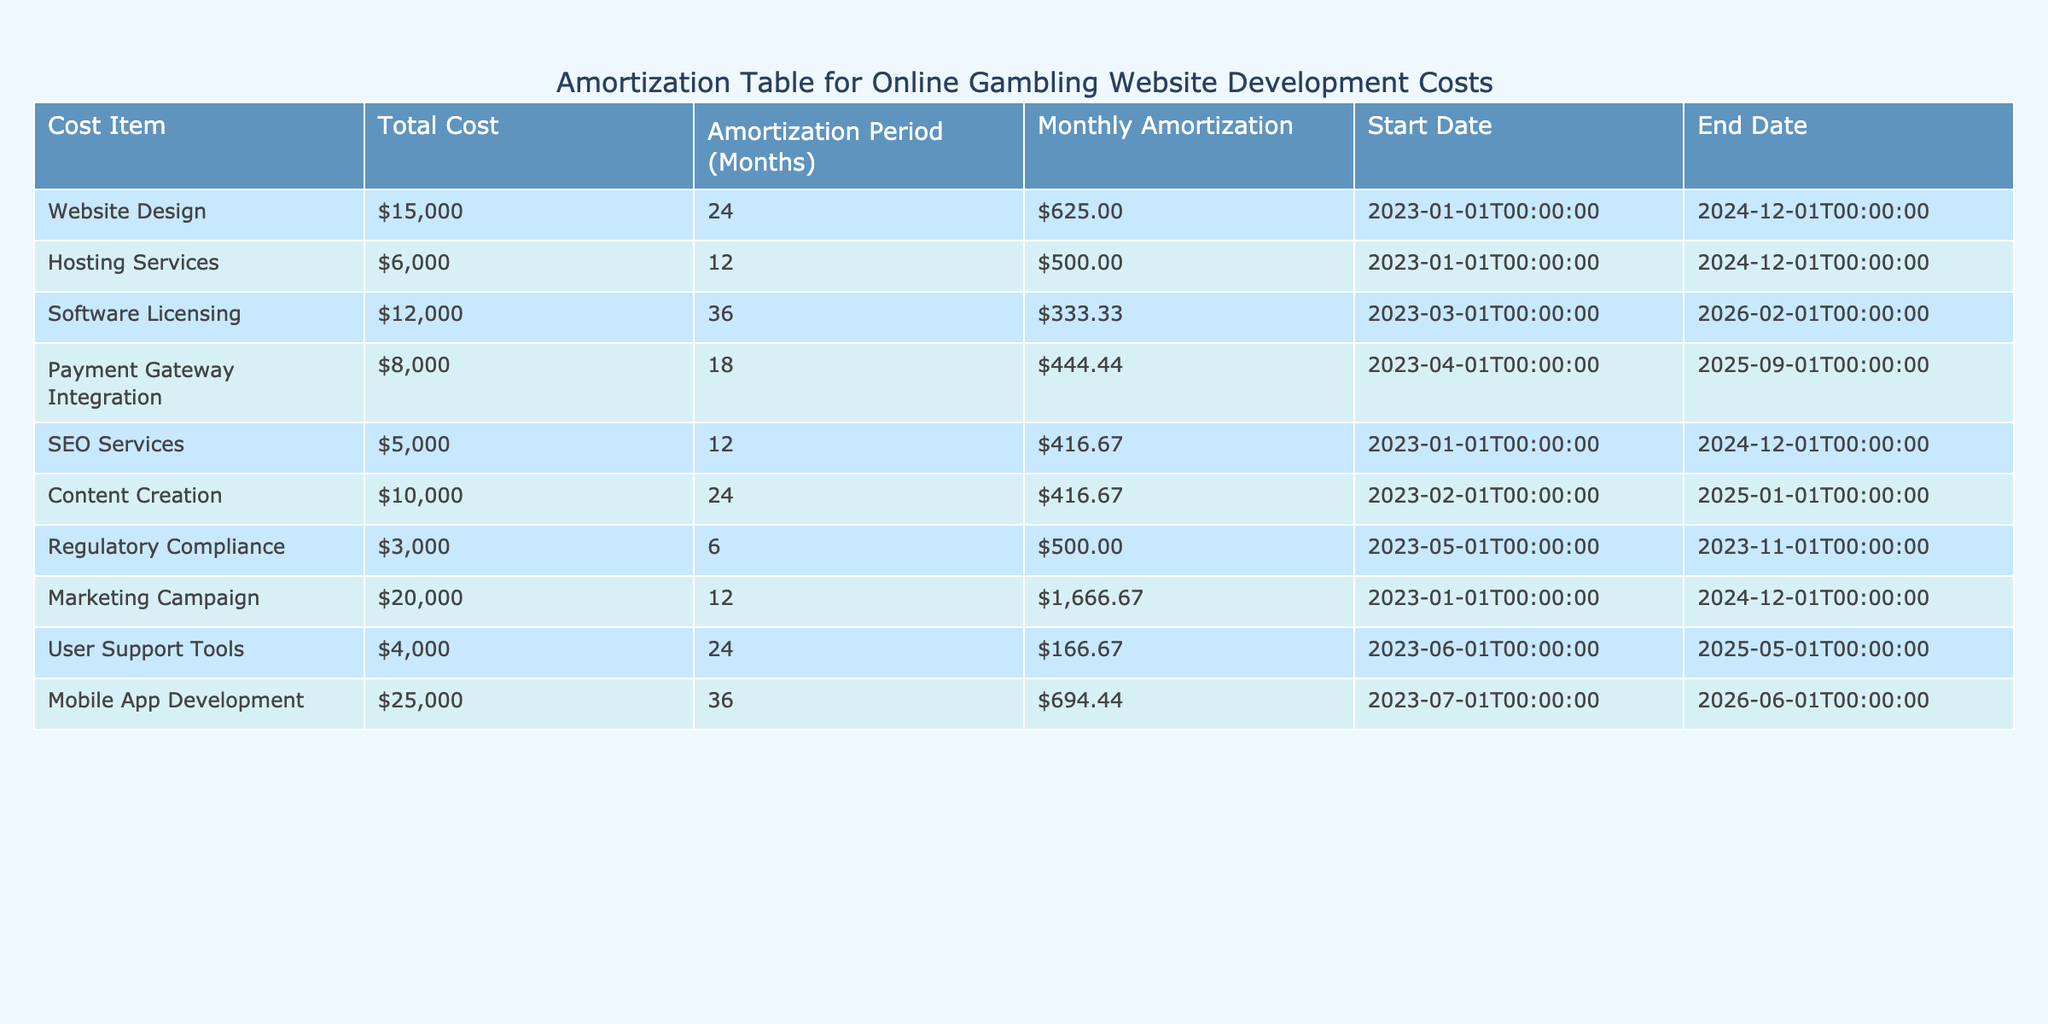What is the monthly amortization for Website Design? The table indicates that the monthly amortization for Website Design is 625.
Answer: 625 What is the total cost for Mobile App Development? According to the table, the total cost for Mobile App Development is 25000.
Answer: 25000 How many months are the Hosting Services amortized over? The table shows that Hosting Services are amortized over 12 months.
Answer: 12 Is the Monthly Amortization for Payment Gateway Integration greater than that of SEO Services? Payment Gateway Integration has a monthly amortization of 444.44, while SEO Services has 416.67. Since 444.44 is greater than 416.67, the statement is true.
Answer: Yes What is the total cost of all the services combined? To find the total cost, sum all the total costs: 15000 + 6000 + 12000 + 8000 + 5000 + 10000 + 3000 + 20000 + 4000 + 25000 = 106000.
Answer: 106000 What is the monthly amortization for the SEO Services? The table specifies that the monthly amortization for SEO Services is 416.67.
Answer: 416.67 Which cost item has the longest amortization period and what is that period? The Software Licensing has the longest amortization period of 36 months according to the table.
Answer: 36 months What is the average monthly amortization across all items? To calculate the average, sum all the monthly amortizations: 625 + 500 + 333.33 + 444.44 + 416.67 + 416.67 + 500 + 1666.67 + 166.67 + 694.44 = 5519.44. Then divide by the number of items (10): 5519.44 / 10 = 551.94.
Answer: 551.94 Is the end date for User Support Tools before that of Content Creation? User Support Tools ends on 2025-05-01 and Content Creation ends on 2025-01-01. Since May is after January, this statement is false.
Answer: No 